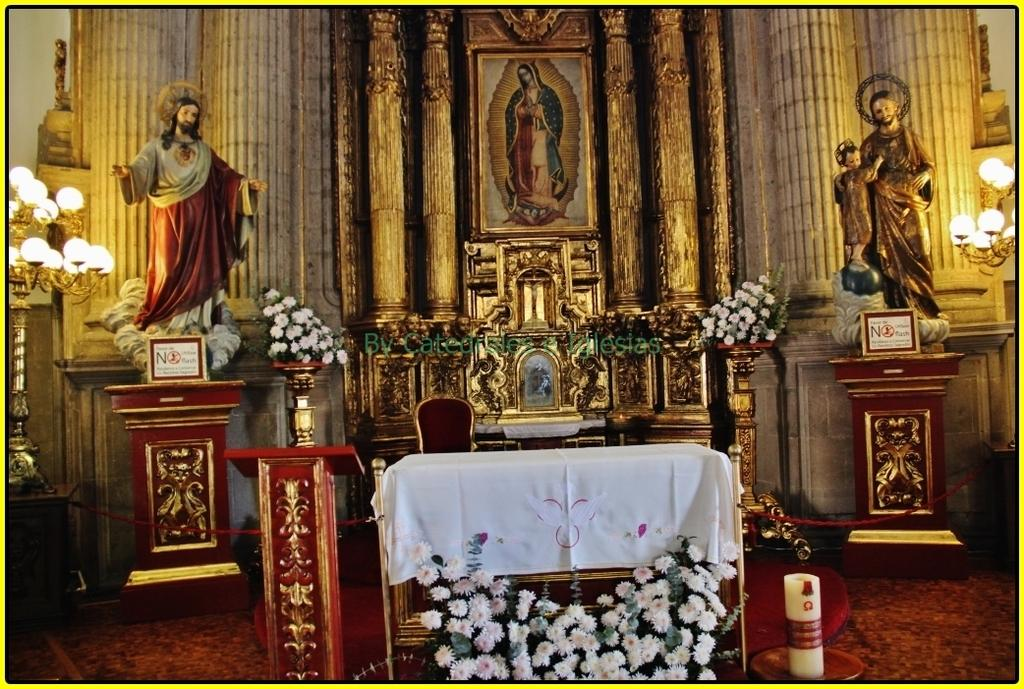What type of building is shown in the image? The image depicts the inside view of a church. What decorative elements can be seen in the image? There are statues, lights, flowers, and frames in the image. What type of crook is present in the image? There is no crook present in the image; it depicts the inside view of a church. Who is the writer of the text in the image? There is no text or writer mentioned in the image; it focuses on the decorative elements of a church. 